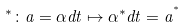<formula> <loc_0><loc_0><loc_500><loc_500>^ { * } \colon a = \alpha d t \mapsto { \alpha } ^ { \ast } d t = a ^ { ^ { * } }</formula> 